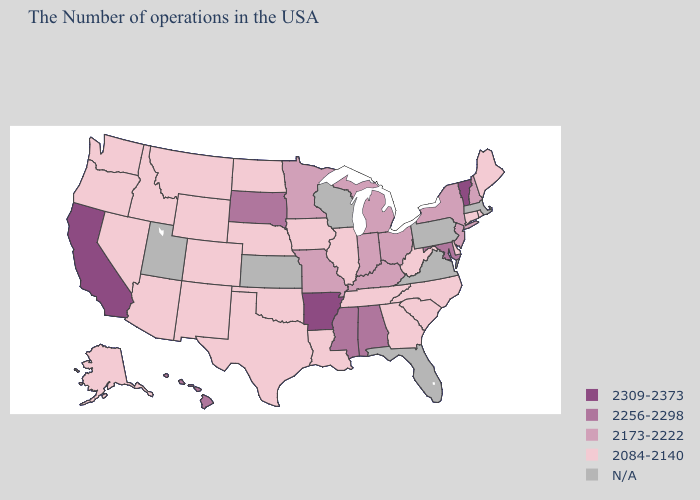Name the states that have a value in the range 2309-2373?
Keep it brief. Vermont, Arkansas, California. Name the states that have a value in the range 2084-2140?
Write a very short answer. Maine, Rhode Island, Connecticut, Delaware, North Carolina, South Carolina, West Virginia, Georgia, Tennessee, Illinois, Louisiana, Iowa, Nebraska, Oklahoma, Texas, North Dakota, Wyoming, Colorado, New Mexico, Montana, Arizona, Idaho, Nevada, Washington, Oregon, Alaska. Name the states that have a value in the range 2256-2298?
Give a very brief answer. Maryland, Alabama, Mississippi, South Dakota, Hawaii. Which states have the highest value in the USA?
Write a very short answer. Vermont, Arkansas, California. Name the states that have a value in the range 2256-2298?
Keep it brief. Maryland, Alabama, Mississippi, South Dakota, Hawaii. Among the states that border South Dakota , does Wyoming have the lowest value?
Keep it brief. Yes. Does Maine have the lowest value in the Northeast?
Short answer required. Yes. What is the value of Idaho?
Quick response, please. 2084-2140. Among the states that border West Virginia , does Maryland have the highest value?
Be succinct. Yes. Does Hawaii have the highest value in the USA?
Be succinct. No. What is the value of Tennessee?
Keep it brief. 2084-2140. Does Arizona have the lowest value in the USA?
Short answer required. Yes. Name the states that have a value in the range 2256-2298?
Keep it brief. Maryland, Alabama, Mississippi, South Dakota, Hawaii. What is the value of Alabama?
Keep it brief. 2256-2298. 